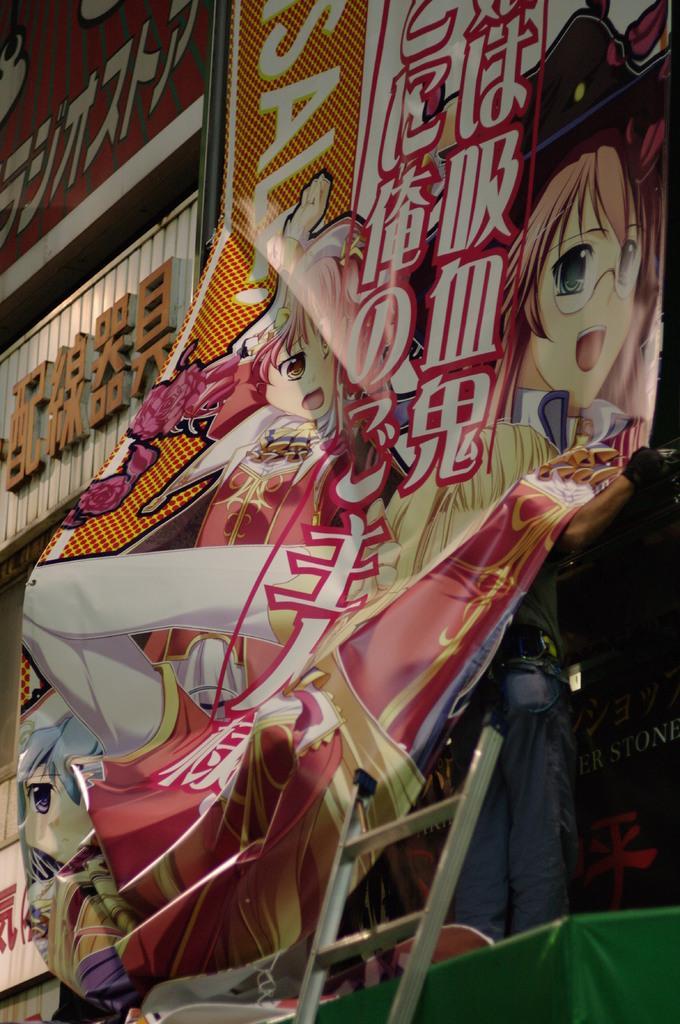Could you give a brief overview of what you see in this image? In this image we can see banners and name boards. On that something is written. Also there are animated characters. At the bottom there is a ladder. 